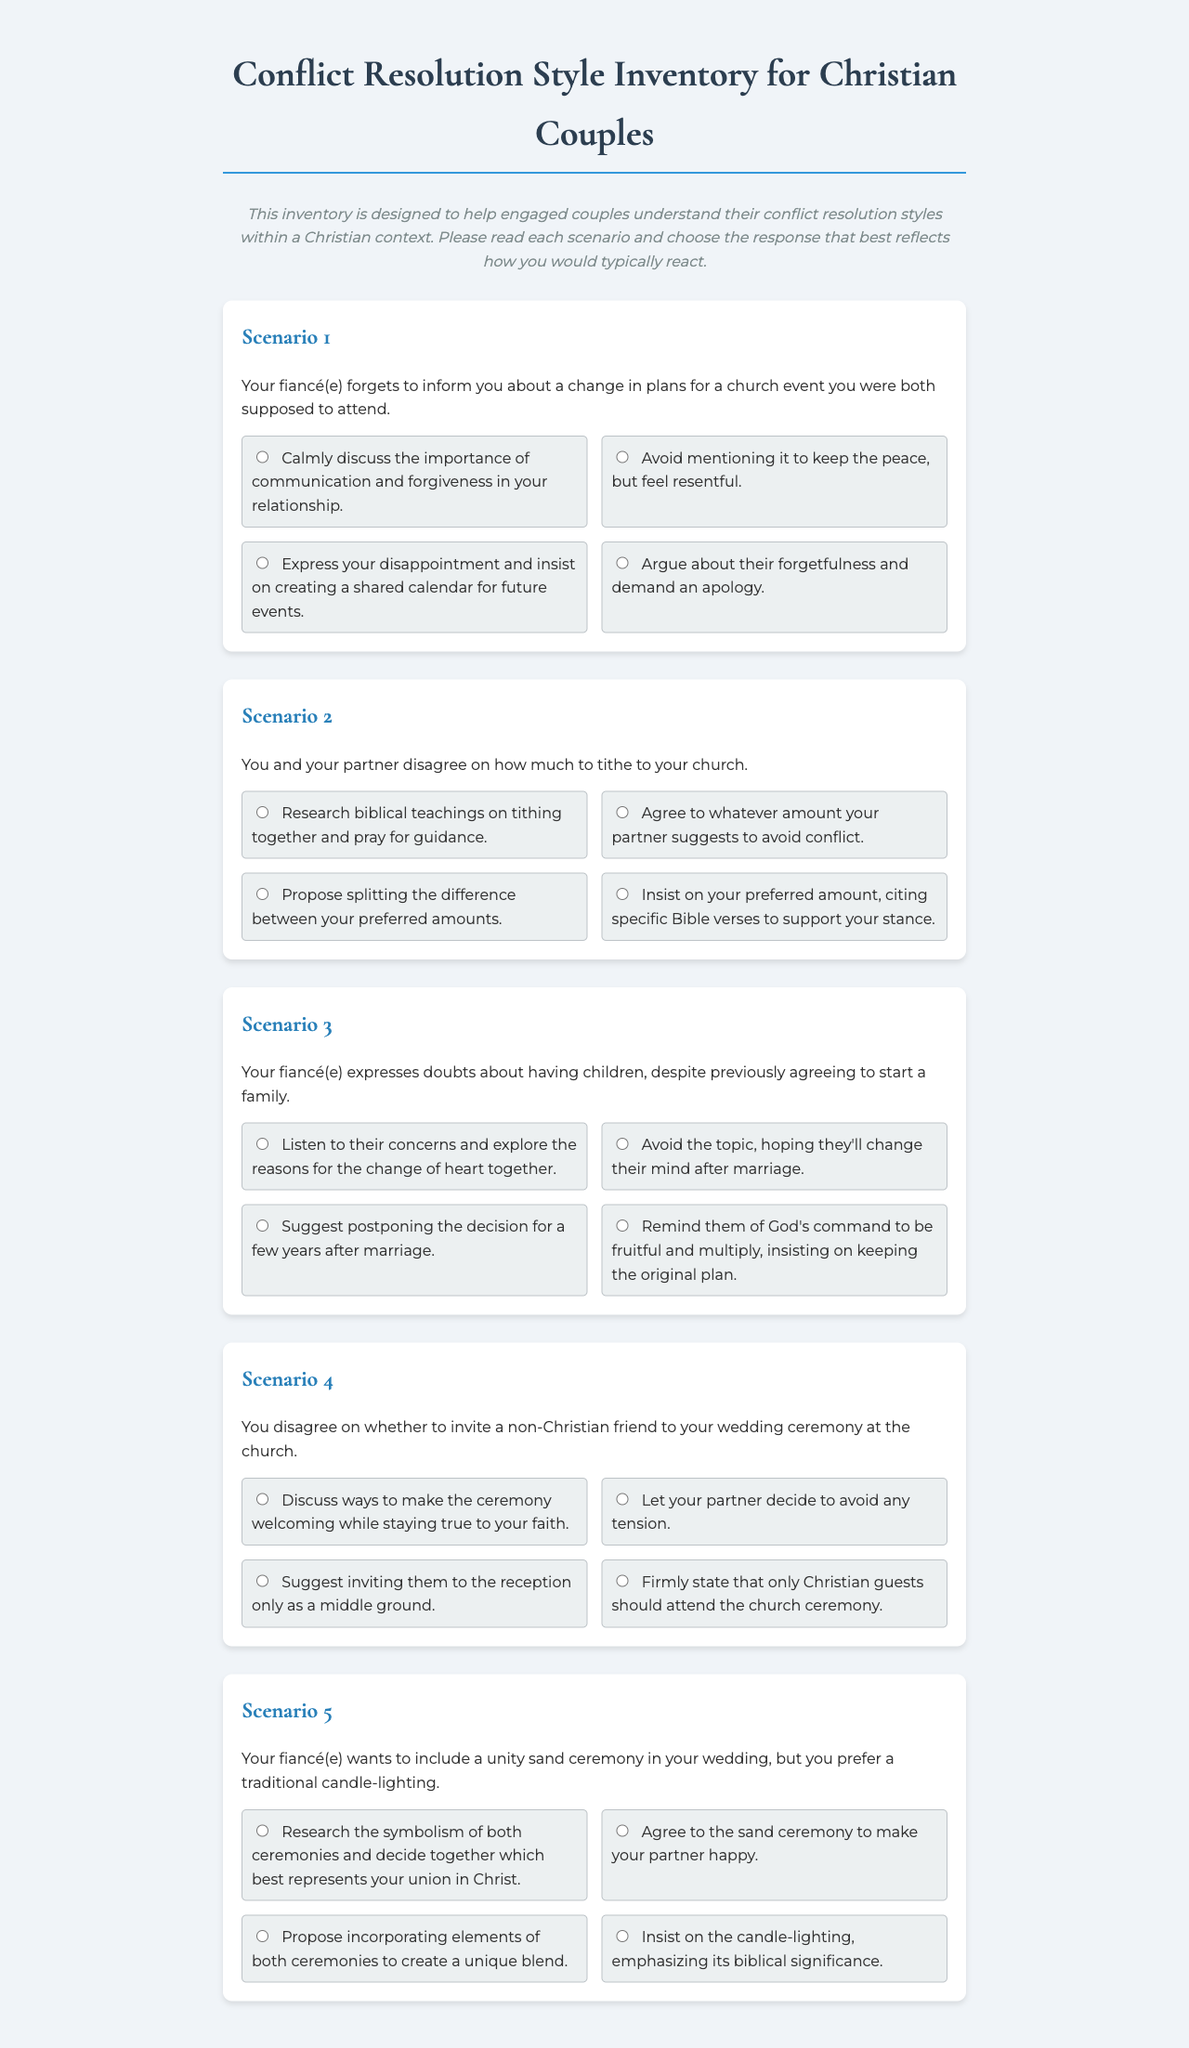What is the title of the document? The title is explicitly stated at the top of the document.
Answer: Conflict Resolution Style Inventory for Christian Couples How many scenarios are included in the inventory? The document lists the scenarios numbered sequentially, and they can be counted.
Answer: 5 What style does the first choice of scenario 2 represent? The styles for each choice are labeled in the document, and the first choice for scenario 2 is labeled accordingly.
Answer: Collaborative What is the scenario presented in scenario 3? The scenario text for scenario 3 can be directly found in the document.
Answer: Your fiancé(e) expresses doubts about having children, despite previously agreeing to start a family Which conflict resolution style is described by the last choice in scenario 4? The style for each choice is provided in the document, and the last choice for scenario 4 outlines its category.
Answer: Competing 